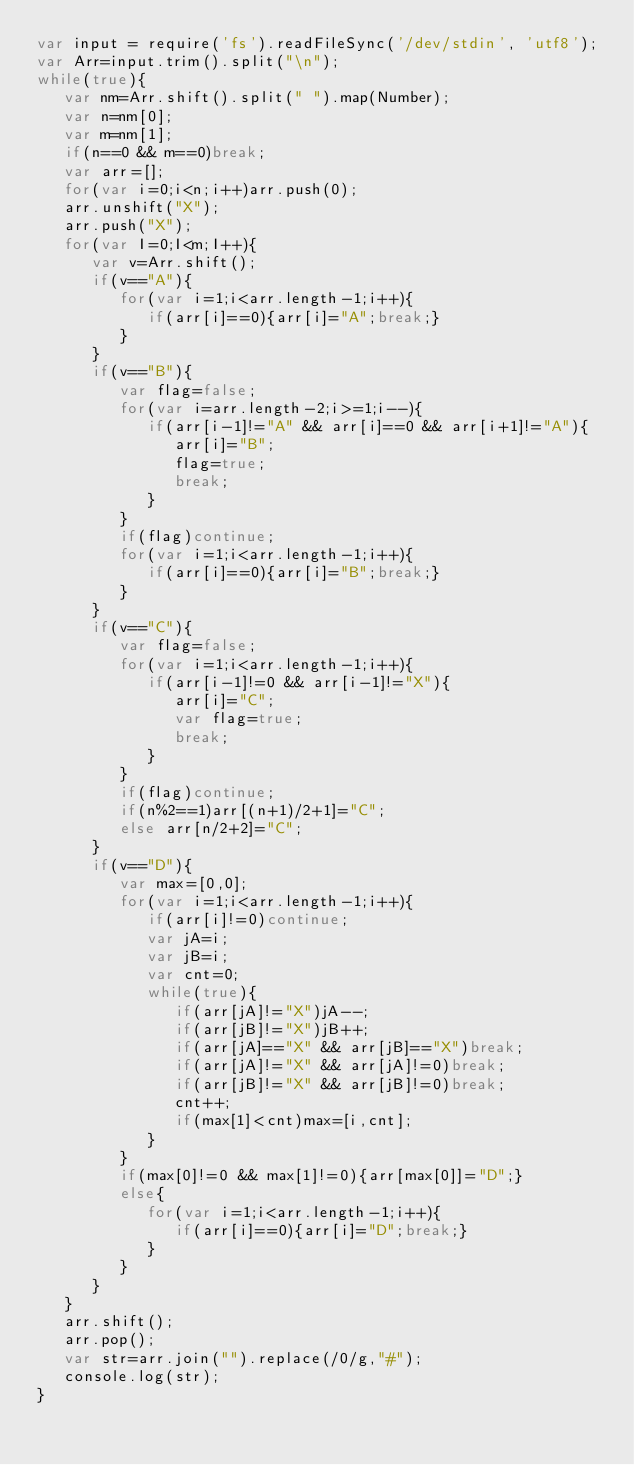<code> <loc_0><loc_0><loc_500><loc_500><_JavaScript_>var input = require('fs').readFileSync('/dev/stdin', 'utf8');
var Arr=input.trim().split("\n");
while(true){
   var nm=Arr.shift().split(" ").map(Number);
   var n=nm[0];
   var m=nm[1];
   if(n==0 && m==0)break;
   var arr=[];
   for(var i=0;i<n;i++)arr.push(0);
   arr.unshift("X");
   arr.push("X");
   for(var I=0;I<m;I++){
      var v=Arr.shift();
      if(v=="A"){
         for(var i=1;i<arr.length-1;i++){
            if(arr[i]==0){arr[i]="A";break;}
         }
      }
      if(v=="B"){
         var flag=false;
         for(var i=arr.length-2;i>=1;i--){
            if(arr[i-1]!="A" && arr[i]==0 && arr[i+1]!="A"){
               arr[i]="B";
               flag=true;
               break;
            }
         }
         if(flag)continue;
         for(var i=1;i<arr.length-1;i++){
            if(arr[i]==0){arr[i]="B";break;}
         }
      }
      if(v=="C"){
         var flag=false;
         for(var i=1;i<arr.length-1;i++){
            if(arr[i-1]!=0 && arr[i-1]!="X"){
               arr[i]="C";
               var flag=true;
               break;
            }
         }
         if(flag)continue;
         if(n%2==1)arr[(n+1)/2+1]="C";
         else arr[n/2+2]="C";
      }
      if(v=="D"){
         var max=[0,0];
         for(var i=1;i<arr.length-1;i++){
            if(arr[i]!=0)continue;
            var jA=i;
            var jB=i;
            var cnt=0;
            while(true){
               if(arr[jA]!="X")jA--;
               if(arr[jB]!="X")jB++;
               if(arr[jA]=="X" && arr[jB]=="X")break;
               if(arr[jA]!="X" && arr[jA]!=0)break;
               if(arr[jB]!="X" && arr[jB]!=0)break;
               cnt++;
               if(max[1]<cnt)max=[i,cnt];
            }
         }
         if(max[0]!=0 && max[1]!=0){arr[max[0]]="D";}
         else{
            for(var i=1;i<arr.length-1;i++){
               if(arr[i]==0){arr[i]="D";break;}
            }
         }
      }
   }
   arr.shift();
   arr.pop();
   var str=arr.join("").replace(/0/g,"#");
   console.log(str);
}</code> 